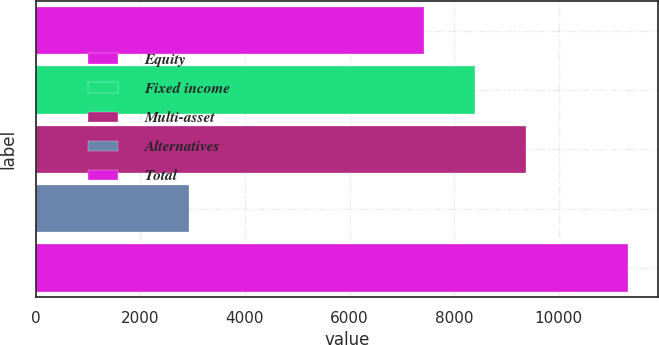<chart> <loc_0><loc_0><loc_500><loc_500><bar_chart><fcel>Equity<fcel>Fixed income<fcel>Multi-asset<fcel>Alternatives<fcel>Total<nl><fcel>7429<fcel>8407<fcel>9367<fcel>2935<fcel>11324<nl></chart> 